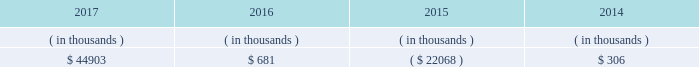All debt and common and preferred stock issuances by entergy texas require prior regulatory approval .
Debt issuances are also subject to issuance tests set forth in its bond indenture and other agreements .
Entergy texas has sufficient capacity under these tests to meet its foreseeable capital needs .
Entergy texas 2019s receivables from or ( payables to ) the money pool were as follows as of december 31 for each of the following years. .
See note 4 to the financial statements for a description of the money pool .
Entergy texas has a credit facility in the amount of $ 150 million scheduled to expire in august 2022 .
The credit facility allows entergy texas to issue letters of credit against $ 30 million of the borrowing capacity of the facility .
As of december 31 , 2017 , there were no cash borrowings and $ 25.6 million of letters of credit outstanding under the credit facility .
In addition , entergy texas is a party to an uncommitted letter of credit facility as a means to post collateral to support its obligations to miso .
As of december 31 , 2017 , a $ 22.8 million letter of credit was outstanding under entergy texas 2019s letter of credit facility .
See note 4 to the financial statements for additional discussion of the credit facilities .
Entergy texas obtained authorizations from the ferc through october 2019 for short-term borrowings , not to exceed an aggregate amount of $ 200 million at any time outstanding , and long-term borrowings and security issuances .
See note 4 to the financial statements for further discussion of entergy texas 2019s short-term borrowing limits .
Entergy texas , inc .
And subsidiaries management 2019s financial discussion and analysis state and local rate regulation and fuel-cost recovery the rates that entergy texas charges for its services significantly influence its financial position , results of operations , and liquidity .
Entergy texas is regulated and the rates charged to its customers are determined in regulatory proceedings .
The puct , a governmental agency , is primarily responsible for approval of the rates charged to customers .
Filings with the puct 2011 rate case in november 2011 , entergy texas filed a rate case requesting a $ 112 million base rate increase reflecting a 10.6% ( 10.6 % ) return on common equity based on an adjusted june 2011 test year . a0 a0the rate case also proposed a purchased power recovery rider . a0 a0on january 12 , 2012 , the puct voted not to address the purchased power recovery rider in the rate case , but the puct voted to set a baseline in the rate case proceeding that would be applicable if a purchased power capacity rider is approved in a separate proceeding . a0 a0in april 2012 the puct staff filed direct testimony recommending a base rate increase of $ 66 million and a 9.6% ( 9.6 % ) return on common equity . a0 a0the puct staff , however , subsequently filed a statement of position in the proceeding indicating that it was still evaluating the position it would ultimately take in the case regarding entergy texas 2019s recovery of purchased power capacity costs and entergy texas 2019s proposal to defer its miso transition expenses . a0 a0in april 2012 , entergy texas filed rebuttal testimony indicating a revised request for a $ 105 million base rate increase . a0 a0a hearing was held in late-april through early-may 2012 .
In september 2012 the puct issued an order approving a $ 28 million rate increase , effective july 2012 . a0 a0the order included a finding that 201ca return on common equity ( roe ) of 9.80 percent will allow [entergy texas] a reasonable opportunity to earn a reasonable return on invested capital . 201d a0 a0the order also provided for increases in depreciation rates and the annual storm reserve accrual . a0 a0the order also reduced entergy texas 2019s proposed purchased power capacity costs , stating that they are not known and measurable ; reduced entergy texas 2019s regulatory assets associated with hurricane rita ; excluded from rate recovery capitalized financially-based incentive compensation ; included $ 1.6 million of miso transition expense in base rates ; and reduced entergy 2019s texas 2019s fuel reconciliation recovery by $ 4 .
What portion of the credit allowance was outstanding on december 31 , 2017 ? ( % (  % ) )? 
Computations: (25.6 / 30)
Answer: 0.85333. 